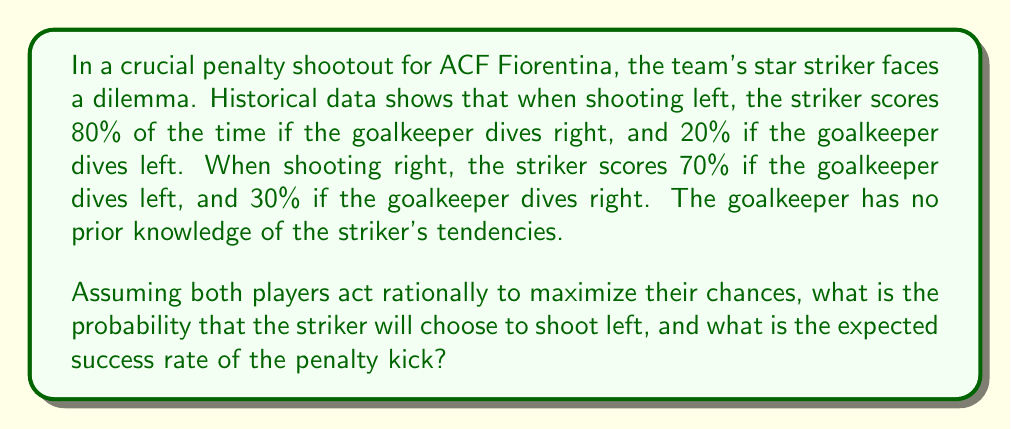Solve this math problem. To solve this problem, we'll use game theory to model the decision-making process. We'll create a payoff matrix and find the mixed strategy Nash equilibrium.

1) First, let's create the payoff matrix:

   $$ \begin{array}{c|cc}
      & \text{GK Left} & \text{GK Right} \\
      \hline
      \text{Shoot Left} & 0.2 & 0.8 \\
      \text{Shoot Right} & 0.7 & 0.3
   \end{array} $$

2) Let $p$ be the probability that the striker shoots left. The goalkeeper's expected payoff for diving left is:
   
   $$ E(\text{GK Left}) = 0.8p + 0.3(1-p) $$

3) The goalkeeper's expected payoff for diving right is:
   
   $$ E(\text{GK Right}) = 0.2p + 0.7(1-p) $$

4) At equilibrium, these should be equal:

   $$ 0.8p + 0.3(1-p) = 0.2p + 0.7(1-p) $$

5) Solving this equation:

   $$ 0.8p + 0.3 - 0.3p = 0.2p + 0.7 - 0.7p $$
   $$ 0.5p + 0.3 = -0.5p + 0.7 $$
   $$ p = 0.4 $$

6) Therefore, the striker should shoot left 40% of the time and right 60% of the time.

7) To calculate the expected success rate, we can use either of the goalkeeper's strategies (as they should be equal at equilibrium):

   $$ E(\text{success}) = 0.2(0.4) + 0.7(0.6) = 0.08 + 0.42 = 0.5 $$

Thus, the expected success rate is 50%.
Answer: The probability that the striker will choose to shoot left is 0.4 (40%), and the expected success rate of the penalty kick is 0.5 (50%). 